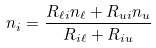<formula> <loc_0><loc_0><loc_500><loc_500>n _ { i } = \frac { R _ { \ell i } n _ { \ell } + R _ { u i } n _ { u } } { R _ { i \ell } + R _ { i u } }</formula> 